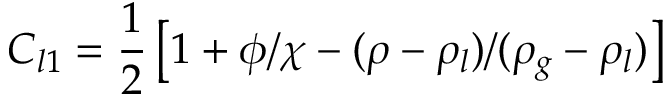<formula> <loc_0><loc_0><loc_500><loc_500>C _ { l 1 } = \frac { 1 } { 2 } \left [ 1 + \phi / \chi - ( \rho - \rho _ { l } ) / ( \rho _ { g } - \rho _ { l } ) \right ]</formula> 